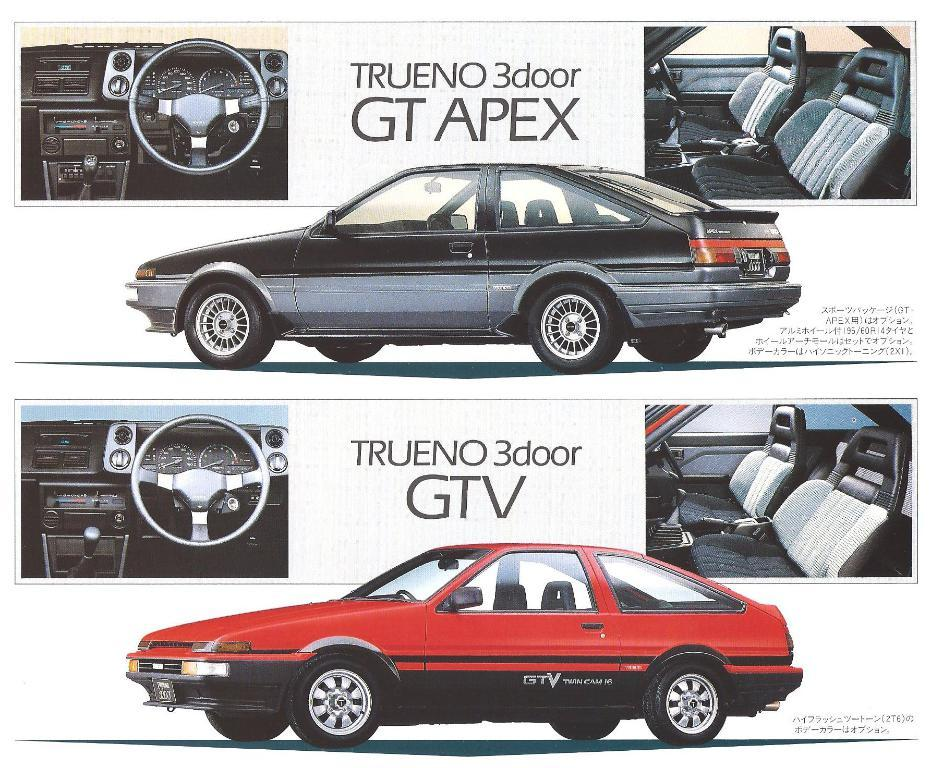What is featured on the poster in the image? The poster contains images of cars. What else can be found on the poster besides the images of cars? There is text on the poster. How many chairs are depicted on the poster? There are no chairs present on the poster; it features images of cars and text. 